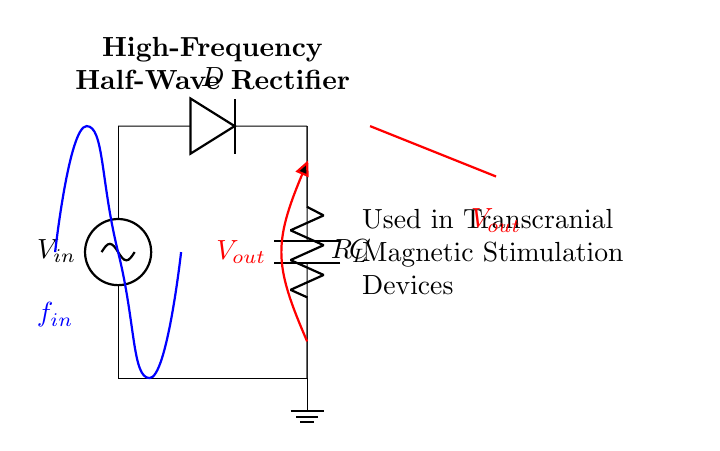What is the input voltage source labeled as? The input voltage source is labeled as V_sub_in, indicating it is the voltage supplied to the circuit.
Answer: V_sub_in What component is represented by the symbol D in the circuit? The symbol D in the circuit diagram represents a diode, which allows current to flow in one direction.
Answer: Diode What role does the capacitor C play in this circuit? The capacitor C smooths the output voltage by storing electrical energy and releasing it, reducing voltage fluctuations.
Answer: Smoothing What is the output voltage labeled as? The output voltage of the circuit is labeled V_sub_out, which represents the processed voltage coming from the rectifier.
Answer: V_sub_out What type of rectifier is shown in this circuit? The circuit diagram depicts a half-wave rectifier because it only uses one diode to rectify the input AC signal.
Answer: Half-wave rectifier How is the load resistor R_L connected in the circuit? The load resistor R_L is connected in parallel with the capacitor C and is crucial for determining the performance of the circuit.
Answer: Parallel Why is this rectifier used in transcranial magnetic stimulation devices? This rectifier is employed because it converts AC power to a usable DC voltage for the stimulation process, necessary for operation.
Answer: Converts AC to DC 